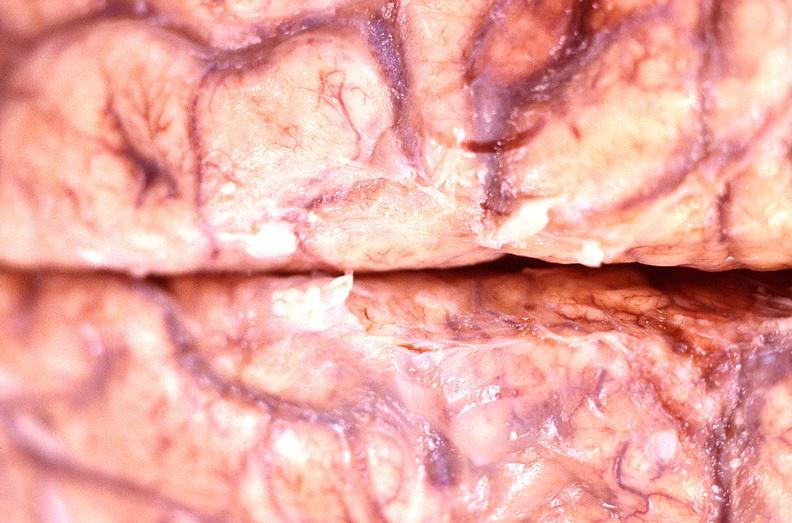what is present?
Answer the question using a single word or phrase. Nervous 